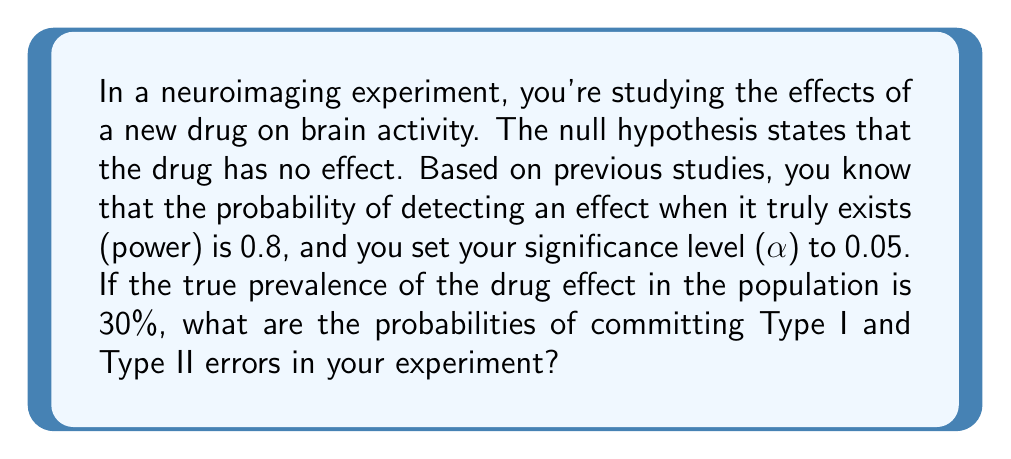Give your solution to this math problem. Let's approach this step-by-step:

1) First, let's define our variables:
   α = significance level = 0.05
   β = probability of Type II error = 1 - power = 1 - 0.8 = 0.2
   P(H1) = true prevalence of drug effect = 0.3
   P(H0) = 1 - P(H1) = 0.7

2) Type I error (α) is the probability of rejecting H0 when it's actually true:
   P(Type I error) = α = 0.05

3) Type II error (β) is the probability of failing to reject H0 when H1 is actually true:
   P(Type II error) = β = 0.2

4) However, the question asks for the probabilities of committing these errors in the experiment, which depends on the prevalence of the effect:

   P(Type I error in experiment) = P(Type I error | H0 true) * P(H0)
                                  = α * (1 - P(H1))
                                  = 0.05 * 0.7
                                  = 0.035

   P(Type II error in experiment) = P(Type II error | H1 true) * P(H1)
                                   = β * P(H1)
                                   = 0.2 * 0.3
                                   = 0.06

Therefore, the probability of committing a Type I error in this experiment is 0.035 or 3.5%, and the probability of committing a Type II error is 0.06 or 6%.
Answer: P(Type I error) = 0.035, P(Type II error) = 0.06 